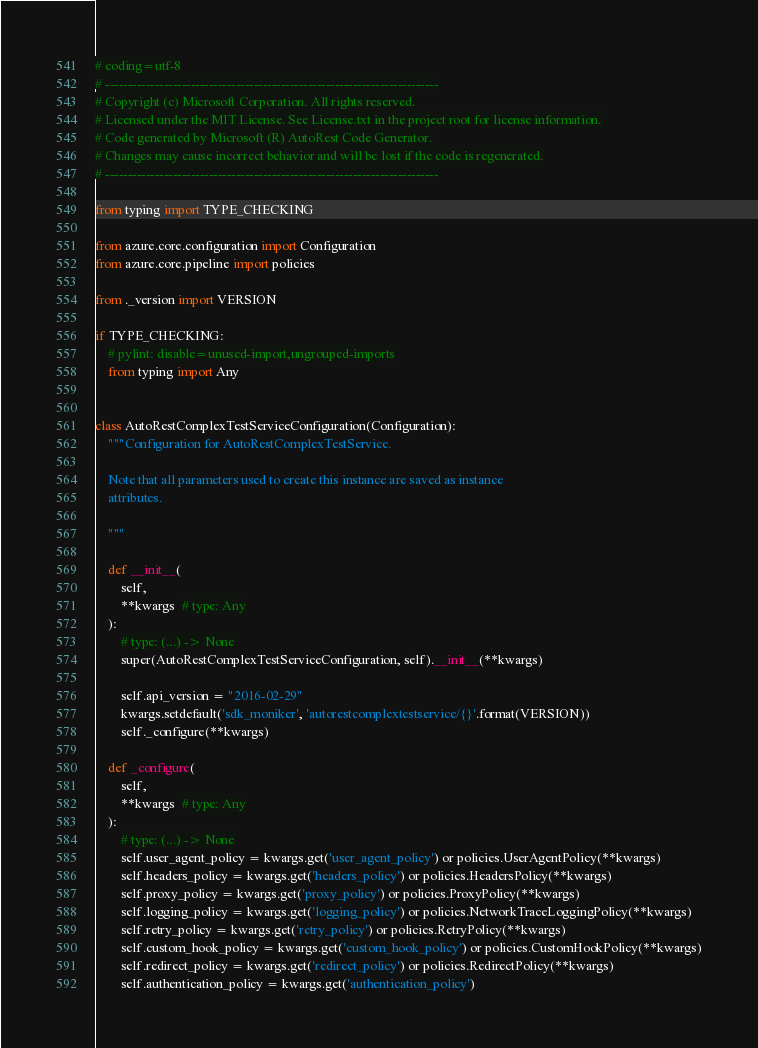<code> <loc_0><loc_0><loc_500><loc_500><_Python_># coding=utf-8
# --------------------------------------------------------------------------
# Copyright (c) Microsoft Corporation. All rights reserved.
# Licensed under the MIT License. See License.txt in the project root for license information.
# Code generated by Microsoft (R) AutoRest Code Generator.
# Changes may cause incorrect behavior and will be lost if the code is regenerated.
# --------------------------------------------------------------------------

from typing import TYPE_CHECKING

from azure.core.configuration import Configuration
from azure.core.pipeline import policies

from ._version import VERSION

if TYPE_CHECKING:
    # pylint: disable=unused-import,ungrouped-imports
    from typing import Any


class AutoRestComplexTestServiceConfiguration(Configuration):
    """Configuration for AutoRestComplexTestService.

    Note that all parameters used to create this instance are saved as instance
    attributes.

    """

    def __init__(
        self,
        **kwargs  # type: Any
    ):
        # type: (...) -> None
        super(AutoRestComplexTestServiceConfiguration, self).__init__(**kwargs)

        self.api_version = "2016-02-29"
        kwargs.setdefault('sdk_moniker', 'autorestcomplextestservice/{}'.format(VERSION))
        self._configure(**kwargs)

    def _configure(
        self,
        **kwargs  # type: Any
    ):
        # type: (...) -> None
        self.user_agent_policy = kwargs.get('user_agent_policy') or policies.UserAgentPolicy(**kwargs)
        self.headers_policy = kwargs.get('headers_policy') or policies.HeadersPolicy(**kwargs)
        self.proxy_policy = kwargs.get('proxy_policy') or policies.ProxyPolicy(**kwargs)
        self.logging_policy = kwargs.get('logging_policy') or policies.NetworkTraceLoggingPolicy(**kwargs)
        self.retry_policy = kwargs.get('retry_policy') or policies.RetryPolicy(**kwargs)
        self.custom_hook_policy = kwargs.get('custom_hook_policy') or policies.CustomHookPolicy(**kwargs)
        self.redirect_policy = kwargs.get('redirect_policy') or policies.RedirectPolicy(**kwargs)
        self.authentication_policy = kwargs.get('authentication_policy')
</code> 